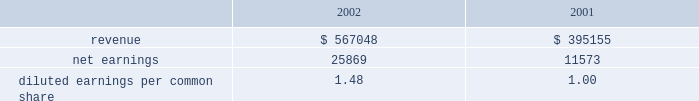Disclosure of , the issuance of certain types of guarantees .
The adoption of fasb interpretation no .
45 did not have a signif- icant impact on the net income or equity of the company .
In january 2003 , fasb interpretation no .
46 , 201cconsolidation of variable interest entities , an interpretation of arb 51 , 201d was issued .
The primary objectives of this interpretation , as amended , are to provide guidance on the identification and consolidation of variable interest entities , or vies , which are entities for which control is achieved through means other than through voting rights .
The company has completed an analysis of this interpretation and has determined that it does not have any vies .
Acquisitions family health plan , inc .
Effective january 1 , 2004 , the company commenced opera- tions in ohio through the acquisition from family health plan , inc .
Of certain medicaid-related assets for a purchase price of approximately $ 6800 .
The cost to acquire the medicaid-related assets will be allocated to the assets acquired and liabilities assumed according to estimated fair values .
Hmo blue texas effective august 1 , 2003 , the company acquired certain medicaid-related contract rights of hmo blue texas in the san antonio , texas market for $ 1045 .
The purchase price was allocated to acquired contracts , which are being amor- tized on a straight-line basis over a period of five years , the expected period of benefit .
Group practice affiliates during 2003 , the company acquired a 100% ( 100 % ) ownership interest in group practice affiliates , llc , a behavioral healthcare services company ( 63.7% ( 63.7 % ) in march 2003 and 36.3% ( 36.3 % ) in august 2003 ) .
The consolidated financial state- ments include the results of operations of gpa since march 1 , 2003 .
The company paid $ 1800 for its purchase of gpa .
The cost to acquire the ownership interest has been allocated to the assets acquired and liabilities assumed according to estimated fair values and is subject to adjustment when additional information concerning asset and liability valuations are finalized .
The preliminary allocation has resulted in goodwill of approximately $ 3895 .
The goodwill is not amortized and is not deductible for tax purposes .
Pro forma disclosures related to the acquisition have been excluded as immaterial .
Scriptassist in march 2003 , the company purchased contract and name rights of scriptassist , llc ( scriptassist ) , a medication com- pliance company .
The purchase price of $ 563 was allocated to acquired contracts , which are being amortized on a straight-line basis over a period of five years , the expected period of benefit .
The investor group who held membership interests in scriptassist included one of the company 2019s executive officers .
University health plans , inc .
On december 1 , 2002 , the company purchased 80% ( 80 % ) of the outstanding capital stock of university health plans , inc .
( uhp ) in new jersey .
In october 2003 , the company exercised its option to purchase the remaining 20% ( 20 % ) of the outstanding capital stock .
Centene paid a total purchase price of $ 13258 .
The results of operations for uhp are included in the consolidated financial statements since december 1 , 2002 .
The acquisition of uhp resulted in identified intangible assets of $ 3800 , representing purchased contract rights and provider network .
The intangibles are being amortized over a ten-year period .
Goodwill of $ 7940 is not amortized and is not deductible for tax purposes .
Changes during 2003 to the preliminary purchase price allocation primarily consisted of the purchase of the remaining 20% ( 20 % ) of the outstanding stock and the recognition of intangible assets and related deferred tax liabilities .
The following unaudited pro forma information presents the results of operations of centene and subsidiaries as if the uhp acquisition described above had occurred as of january 1 , 2001 .
These pro forma results may not necessar- ily reflect the actual results of operations that would have been achieved , nor are they necessarily indicative of future results of operations. .
Diluted earnings per common share 1.48 1.00 texas universities health plan in june 2002 , the company purchased schip contracts in three texas service areas .
The cash purchase price of $ 595 was recorded as purchased contract rights , which are being amortized on a straight-line basis over five years , the expected period of benefit .
Bankers reserve in march 2002 , the company acquired bankers reserve life insurance company of wisconsin for a cash purchase price of $ 3527 .
The company allocated the purchase price to net tangible and identifiable intangible assets based on their fair value .
Centene allocated $ 479 to identifiable intangible assets , representing the value assigned to acquired licenses , which are being amortized on a straight-line basis over a notes to consolidated financial statements ( continued ) centene corporation and subsidiaries .
What was the percentage change in pro forma diluted earnings per common share from 2001 to 2002? 
Computations: ((1.48 - 1.00) / 1.00)
Answer: 0.48. 